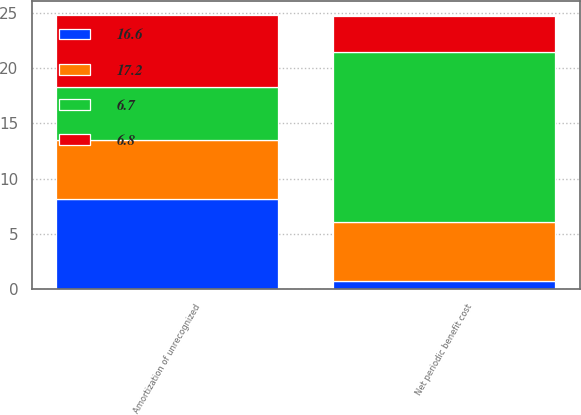Convert chart to OTSL. <chart><loc_0><loc_0><loc_500><loc_500><stacked_bar_chart><ecel><fcel>Amortization of unrecognized<fcel>Net periodic benefit cost<nl><fcel>6.8<fcel>6.5<fcel>3.3<nl><fcel>6.7<fcel>4.8<fcel>15.3<nl><fcel>16.6<fcel>8.2<fcel>0.8<nl><fcel>17.2<fcel>5.3<fcel>5.3<nl></chart> 